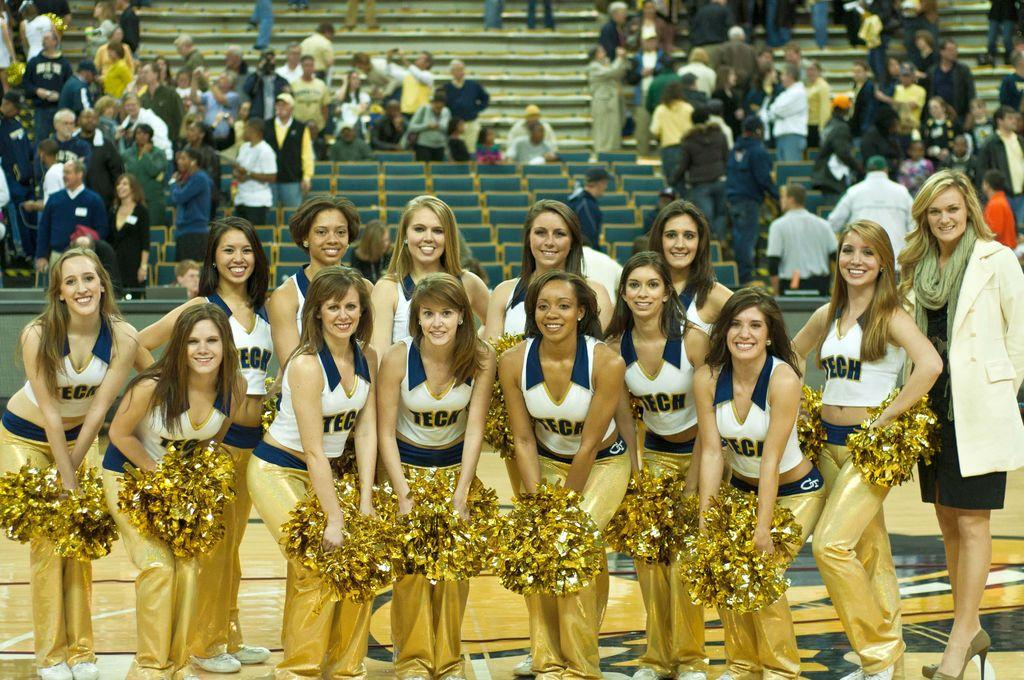<image>
Relay a brief, clear account of the picture shown. A group of cheerleaders for TECH with a crowd behind. 